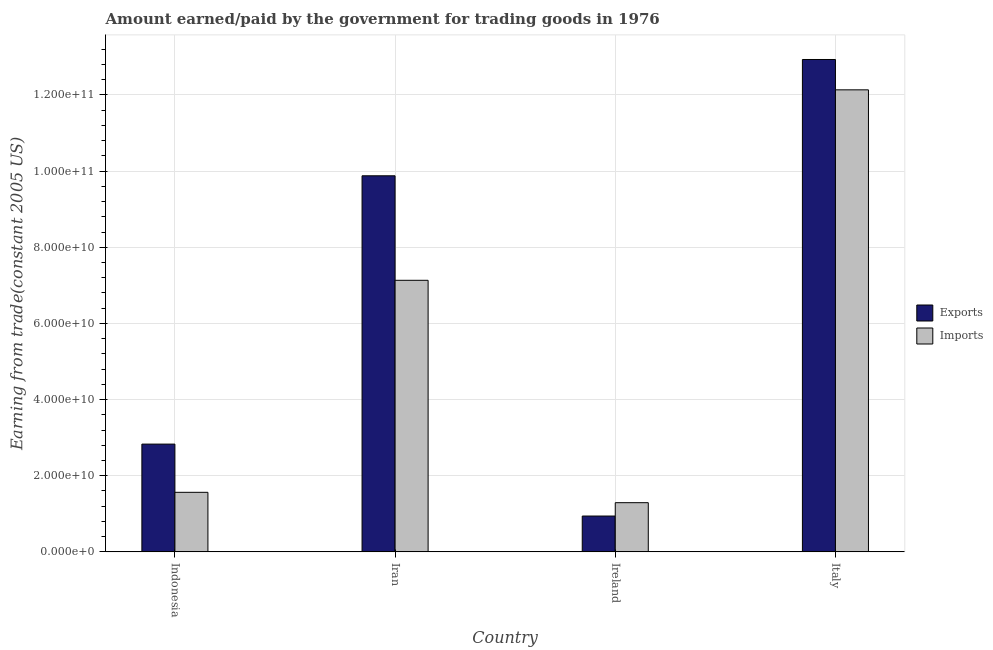How many different coloured bars are there?
Keep it short and to the point. 2. How many groups of bars are there?
Make the answer very short. 4. Are the number of bars on each tick of the X-axis equal?
Make the answer very short. Yes. How many bars are there on the 3rd tick from the left?
Offer a terse response. 2. How many bars are there on the 3rd tick from the right?
Offer a terse response. 2. What is the label of the 3rd group of bars from the left?
Your response must be concise. Ireland. In how many cases, is the number of bars for a given country not equal to the number of legend labels?
Provide a succinct answer. 0. What is the amount earned from exports in Indonesia?
Make the answer very short. 2.83e+1. Across all countries, what is the maximum amount earned from exports?
Provide a succinct answer. 1.29e+11. Across all countries, what is the minimum amount earned from exports?
Offer a terse response. 9.41e+09. In which country was the amount earned from exports minimum?
Ensure brevity in your answer.  Ireland. What is the total amount earned from exports in the graph?
Make the answer very short. 2.66e+11. What is the difference between the amount paid for imports in Indonesia and that in Italy?
Your answer should be very brief. -1.06e+11. What is the difference between the amount paid for imports in Iran and the amount earned from exports in Ireland?
Provide a short and direct response. 6.19e+1. What is the average amount earned from exports per country?
Offer a terse response. 6.65e+1. What is the difference between the amount earned from exports and amount paid for imports in Indonesia?
Your response must be concise. 1.27e+1. In how many countries, is the amount earned from exports greater than 4000000000 US$?
Your answer should be compact. 4. What is the ratio of the amount paid for imports in Iran to that in Italy?
Your answer should be very brief. 0.59. Is the amount earned from exports in Indonesia less than that in Ireland?
Provide a short and direct response. No. Is the difference between the amount earned from exports in Iran and Italy greater than the difference between the amount paid for imports in Iran and Italy?
Offer a terse response. Yes. What is the difference between the highest and the second highest amount earned from exports?
Keep it short and to the point. 3.05e+1. What is the difference between the highest and the lowest amount paid for imports?
Your answer should be very brief. 1.08e+11. Is the sum of the amount earned from exports in Iran and Ireland greater than the maximum amount paid for imports across all countries?
Offer a very short reply. No. What does the 1st bar from the left in Iran represents?
Your response must be concise. Exports. What does the 1st bar from the right in Ireland represents?
Give a very brief answer. Imports. How many bars are there?
Ensure brevity in your answer.  8. Are the values on the major ticks of Y-axis written in scientific E-notation?
Provide a succinct answer. Yes. How many legend labels are there?
Your answer should be compact. 2. What is the title of the graph?
Your answer should be very brief. Amount earned/paid by the government for trading goods in 1976. What is the label or title of the X-axis?
Offer a very short reply. Country. What is the label or title of the Y-axis?
Offer a terse response. Earning from trade(constant 2005 US). What is the Earning from trade(constant 2005 US) in Exports in Indonesia?
Ensure brevity in your answer.  2.83e+1. What is the Earning from trade(constant 2005 US) in Imports in Indonesia?
Provide a succinct answer. 1.56e+1. What is the Earning from trade(constant 2005 US) of Exports in Iran?
Offer a very short reply. 9.88e+1. What is the Earning from trade(constant 2005 US) in Imports in Iran?
Keep it short and to the point. 7.13e+1. What is the Earning from trade(constant 2005 US) of Exports in Ireland?
Your answer should be compact. 9.41e+09. What is the Earning from trade(constant 2005 US) in Imports in Ireland?
Your answer should be very brief. 1.29e+1. What is the Earning from trade(constant 2005 US) in Exports in Italy?
Give a very brief answer. 1.29e+11. What is the Earning from trade(constant 2005 US) of Imports in Italy?
Make the answer very short. 1.21e+11. Across all countries, what is the maximum Earning from trade(constant 2005 US) of Exports?
Keep it short and to the point. 1.29e+11. Across all countries, what is the maximum Earning from trade(constant 2005 US) in Imports?
Keep it short and to the point. 1.21e+11. Across all countries, what is the minimum Earning from trade(constant 2005 US) of Exports?
Provide a succinct answer. 9.41e+09. Across all countries, what is the minimum Earning from trade(constant 2005 US) in Imports?
Offer a very short reply. 1.29e+1. What is the total Earning from trade(constant 2005 US) of Exports in the graph?
Ensure brevity in your answer.  2.66e+11. What is the total Earning from trade(constant 2005 US) of Imports in the graph?
Offer a very short reply. 2.21e+11. What is the difference between the Earning from trade(constant 2005 US) in Exports in Indonesia and that in Iran?
Your answer should be compact. -7.05e+1. What is the difference between the Earning from trade(constant 2005 US) of Imports in Indonesia and that in Iran?
Make the answer very short. -5.57e+1. What is the difference between the Earning from trade(constant 2005 US) of Exports in Indonesia and that in Ireland?
Give a very brief answer. 1.89e+1. What is the difference between the Earning from trade(constant 2005 US) of Imports in Indonesia and that in Ireland?
Your response must be concise. 2.72e+09. What is the difference between the Earning from trade(constant 2005 US) of Exports in Indonesia and that in Italy?
Ensure brevity in your answer.  -1.01e+11. What is the difference between the Earning from trade(constant 2005 US) in Imports in Indonesia and that in Italy?
Your answer should be very brief. -1.06e+11. What is the difference between the Earning from trade(constant 2005 US) in Exports in Iran and that in Ireland?
Ensure brevity in your answer.  8.94e+1. What is the difference between the Earning from trade(constant 2005 US) of Imports in Iran and that in Ireland?
Your answer should be very brief. 5.84e+1. What is the difference between the Earning from trade(constant 2005 US) in Exports in Iran and that in Italy?
Give a very brief answer. -3.05e+1. What is the difference between the Earning from trade(constant 2005 US) in Imports in Iran and that in Italy?
Provide a short and direct response. -5.00e+1. What is the difference between the Earning from trade(constant 2005 US) in Exports in Ireland and that in Italy?
Make the answer very short. -1.20e+11. What is the difference between the Earning from trade(constant 2005 US) of Imports in Ireland and that in Italy?
Keep it short and to the point. -1.08e+11. What is the difference between the Earning from trade(constant 2005 US) in Exports in Indonesia and the Earning from trade(constant 2005 US) in Imports in Iran?
Your answer should be compact. -4.30e+1. What is the difference between the Earning from trade(constant 2005 US) of Exports in Indonesia and the Earning from trade(constant 2005 US) of Imports in Ireland?
Give a very brief answer. 1.54e+1. What is the difference between the Earning from trade(constant 2005 US) in Exports in Indonesia and the Earning from trade(constant 2005 US) in Imports in Italy?
Provide a short and direct response. -9.30e+1. What is the difference between the Earning from trade(constant 2005 US) of Exports in Iran and the Earning from trade(constant 2005 US) of Imports in Ireland?
Give a very brief answer. 8.59e+1. What is the difference between the Earning from trade(constant 2005 US) of Exports in Iran and the Earning from trade(constant 2005 US) of Imports in Italy?
Offer a terse response. -2.26e+1. What is the difference between the Earning from trade(constant 2005 US) of Exports in Ireland and the Earning from trade(constant 2005 US) of Imports in Italy?
Your answer should be very brief. -1.12e+11. What is the average Earning from trade(constant 2005 US) in Exports per country?
Ensure brevity in your answer.  6.65e+1. What is the average Earning from trade(constant 2005 US) in Imports per country?
Make the answer very short. 5.53e+1. What is the difference between the Earning from trade(constant 2005 US) of Exports and Earning from trade(constant 2005 US) of Imports in Indonesia?
Offer a very short reply. 1.27e+1. What is the difference between the Earning from trade(constant 2005 US) in Exports and Earning from trade(constant 2005 US) in Imports in Iran?
Give a very brief answer. 2.74e+1. What is the difference between the Earning from trade(constant 2005 US) in Exports and Earning from trade(constant 2005 US) in Imports in Ireland?
Make the answer very short. -3.51e+09. What is the difference between the Earning from trade(constant 2005 US) in Exports and Earning from trade(constant 2005 US) in Imports in Italy?
Offer a very short reply. 7.97e+09. What is the ratio of the Earning from trade(constant 2005 US) in Exports in Indonesia to that in Iran?
Your answer should be very brief. 0.29. What is the ratio of the Earning from trade(constant 2005 US) in Imports in Indonesia to that in Iran?
Offer a very short reply. 0.22. What is the ratio of the Earning from trade(constant 2005 US) of Exports in Indonesia to that in Ireland?
Provide a short and direct response. 3.01. What is the ratio of the Earning from trade(constant 2005 US) of Imports in Indonesia to that in Ireland?
Your answer should be very brief. 1.21. What is the ratio of the Earning from trade(constant 2005 US) of Exports in Indonesia to that in Italy?
Make the answer very short. 0.22. What is the ratio of the Earning from trade(constant 2005 US) of Imports in Indonesia to that in Italy?
Your response must be concise. 0.13. What is the ratio of the Earning from trade(constant 2005 US) in Exports in Iran to that in Ireland?
Ensure brevity in your answer.  10.49. What is the ratio of the Earning from trade(constant 2005 US) of Imports in Iran to that in Ireland?
Your answer should be very brief. 5.52. What is the ratio of the Earning from trade(constant 2005 US) of Exports in Iran to that in Italy?
Provide a succinct answer. 0.76. What is the ratio of the Earning from trade(constant 2005 US) of Imports in Iran to that in Italy?
Provide a short and direct response. 0.59. What is the ratio of the Earning from trade(constant 2005 US) of Exports in Ireland to that in Italy?
Your answer should be very brief. 0.07. What is the ratio of the Earning from trade(constant 2005 US) in Imports in Ireland to that in Italy?
Provide a succinct answer. 0.11. What is the difference between the highest and the second highest Earning from trade(constant 2005 US) of Exports?
Offer a very short reply. 3.05e+1. What is the difference between the highest and the second highest Earning from trade(constant 2005 US) in Imports?
Offer a very short reply. 5.00e+1. What is the difference between the highest and the lowest Earning from trade(constant 2005 US) in Exports?
Make the answer very short. 1.20e+11. What is the difference between the highest and the lowest Earning from trade(constant 2005 US) in Imports?
Make the answer very short. 1.08e+11. 